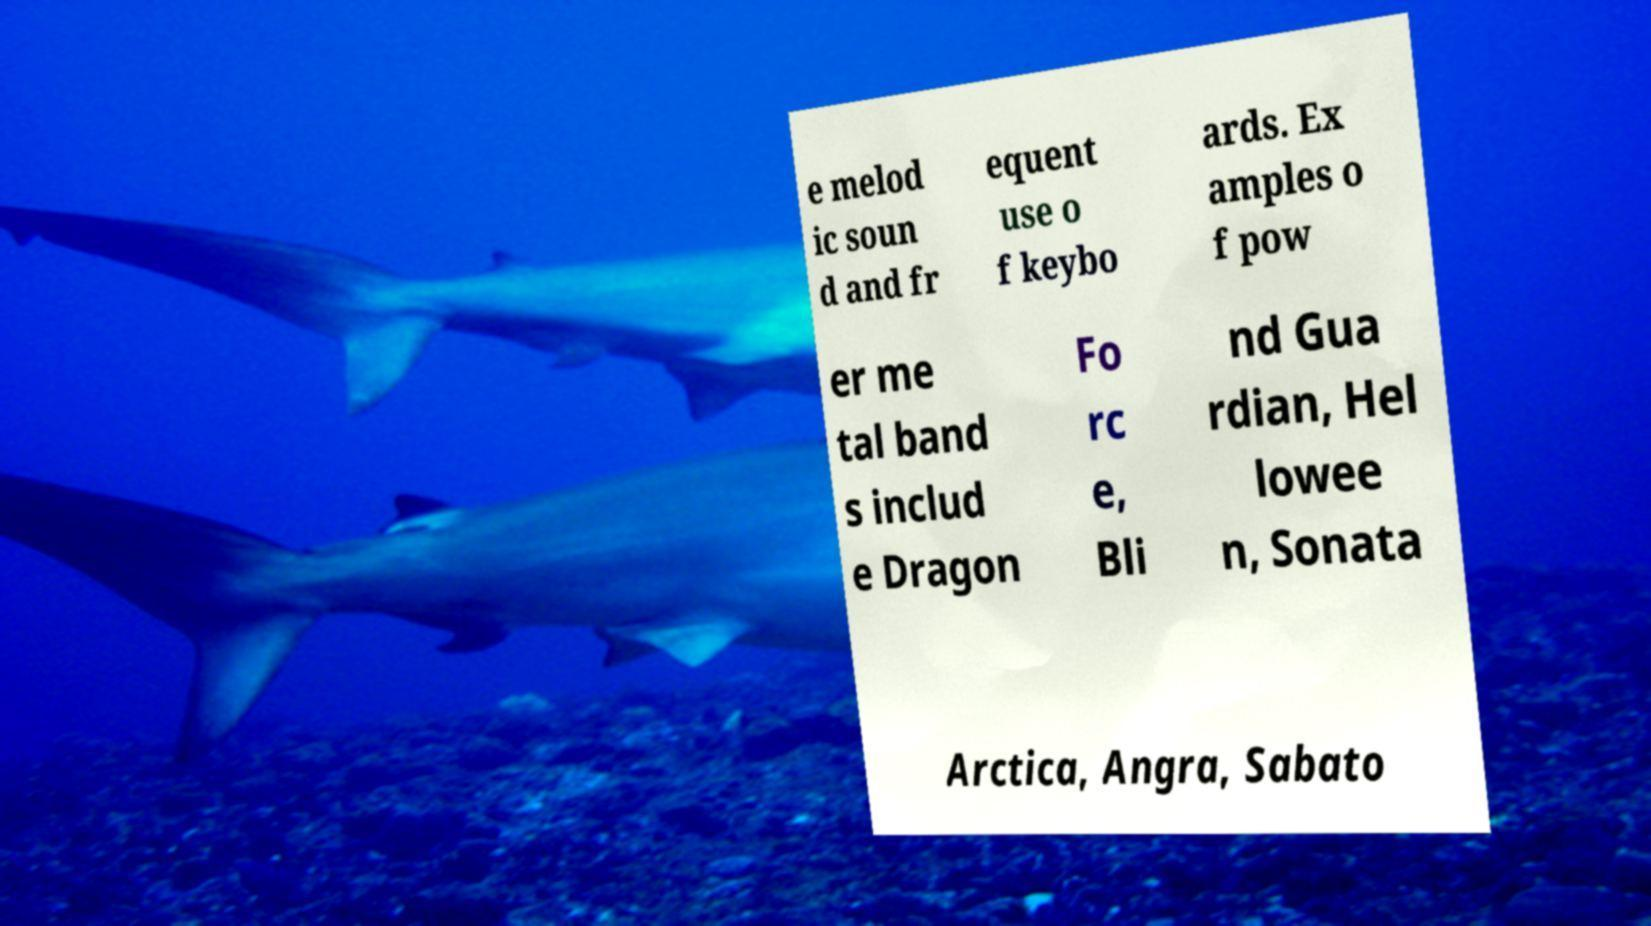Please identify and transcribe the text found in this image. e melod ic soun d and fr equent use o f keybo ards. Ex amples o f pow er me tal band s includ e Dragon Fo rc e, Bli nd Gua rdian, Hel lowee n, Sonata Arctica, Angra, Sabato 